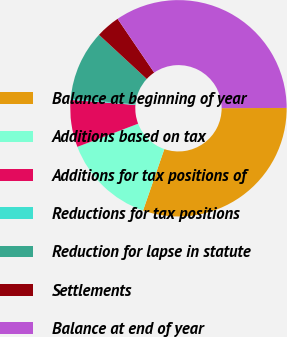<chart> <loc_0><loc_0><loc_500><loc_500><pie_chart><fcel>Balance at beginning of year<fcel>Additions based on tax<fcel>Additions for tax positions of<fcel>Reductions for tax positions<fcel>Reduction for lapse in statute<fcel>Settlements<fcel>Balance at end of year<nl><fcel>30.36%<fcel>13.89%<fcel>7.04%<fcel>0.18%<fcel>10.46%<fcel>3.61%<fcel>34.46%<nl></chart> 